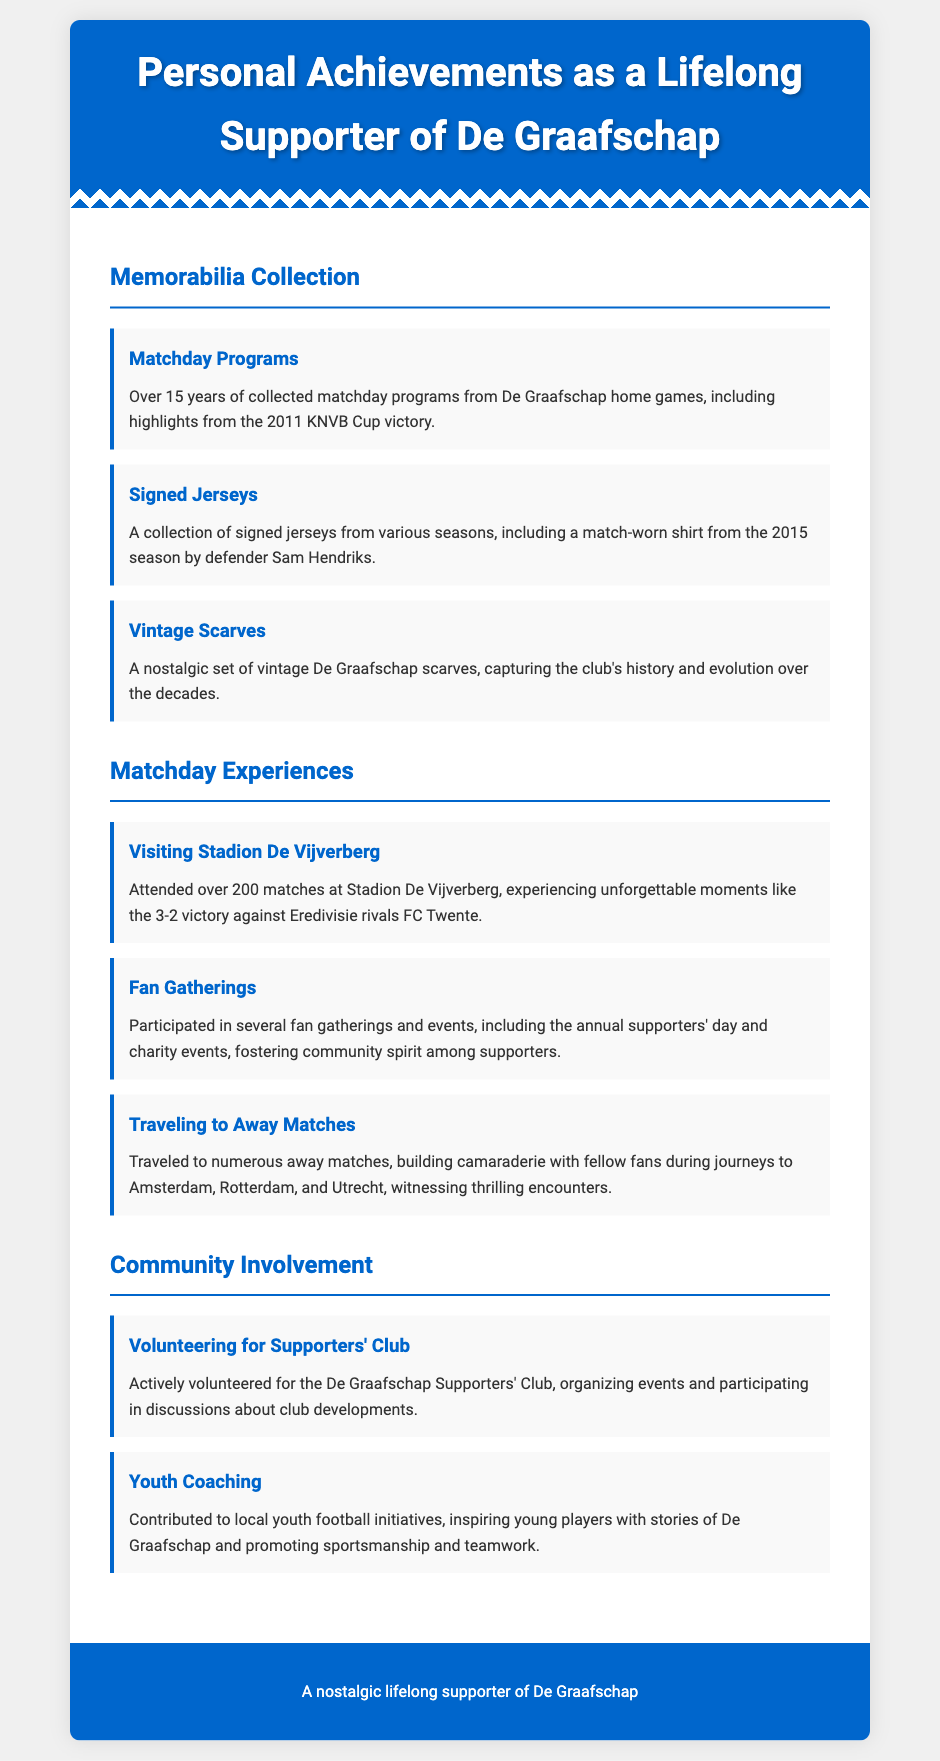What is the total number of matchday programs collected? The document states "Over 15 years of collected matchday programs," but does not specify an exact count.
Answer: Over 15 years What notable victory is highlighted in the matchday programs? The document mentions "highlights from the 2011 KNVB Cup victory."
Answer: 2011 KNVB Cup victory Who is the player associated with the signed match-worn shirt from the 2015 season? The document specifies "defender Sam Hendriks" as the player from whom the shirt is match-worn.
Answer: Sam Hendriks How many matches have been attended at Stadion De Vijverberg? The text states "Attended over 200 matches at Stadion De Vijverberg."
Answer: Over 200 matches What major  match result is recalled in the matchday experiences? The document recalls a "3-2 victory against Eredivisie rivals FC Twente."
Answer: 3-2 victory against FC Twente What type of events does the supporter participate in for community involvement? The document mentions "the annual supporters' day and charity events."
Answer: Annual supporters' day and charity events In what areas does the supporter contribute to youth football initiatives? The document states the supporter "inspiring young players with stories of De Graafschap."
Answer: Inspiring young players How long has the supporter been collecting memorabilia? The text specifies "Over 15 years of collected matchday programs."
Answer: Over 15 years What is the main focus of the supporter’s active volunteering? The document mentions "organizing events and participating in discussions about club developments."
Answer: Organizing events and discussions 